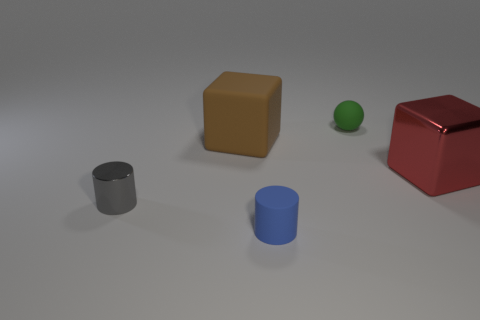Add 4 large red metal cylinders. How many objects exist? 9 Subtract all balls. How many objects are left? 4 Add 5 small brown rubber balls. How many small brown rubber balls exist? 5 Subtract 0 green cylinders. How many objects are left? 5 Subtract all small blue things. Subtract all cylinders. How many objects are left? 2 Add 1 matte objects. How many matte objects are left? 4 